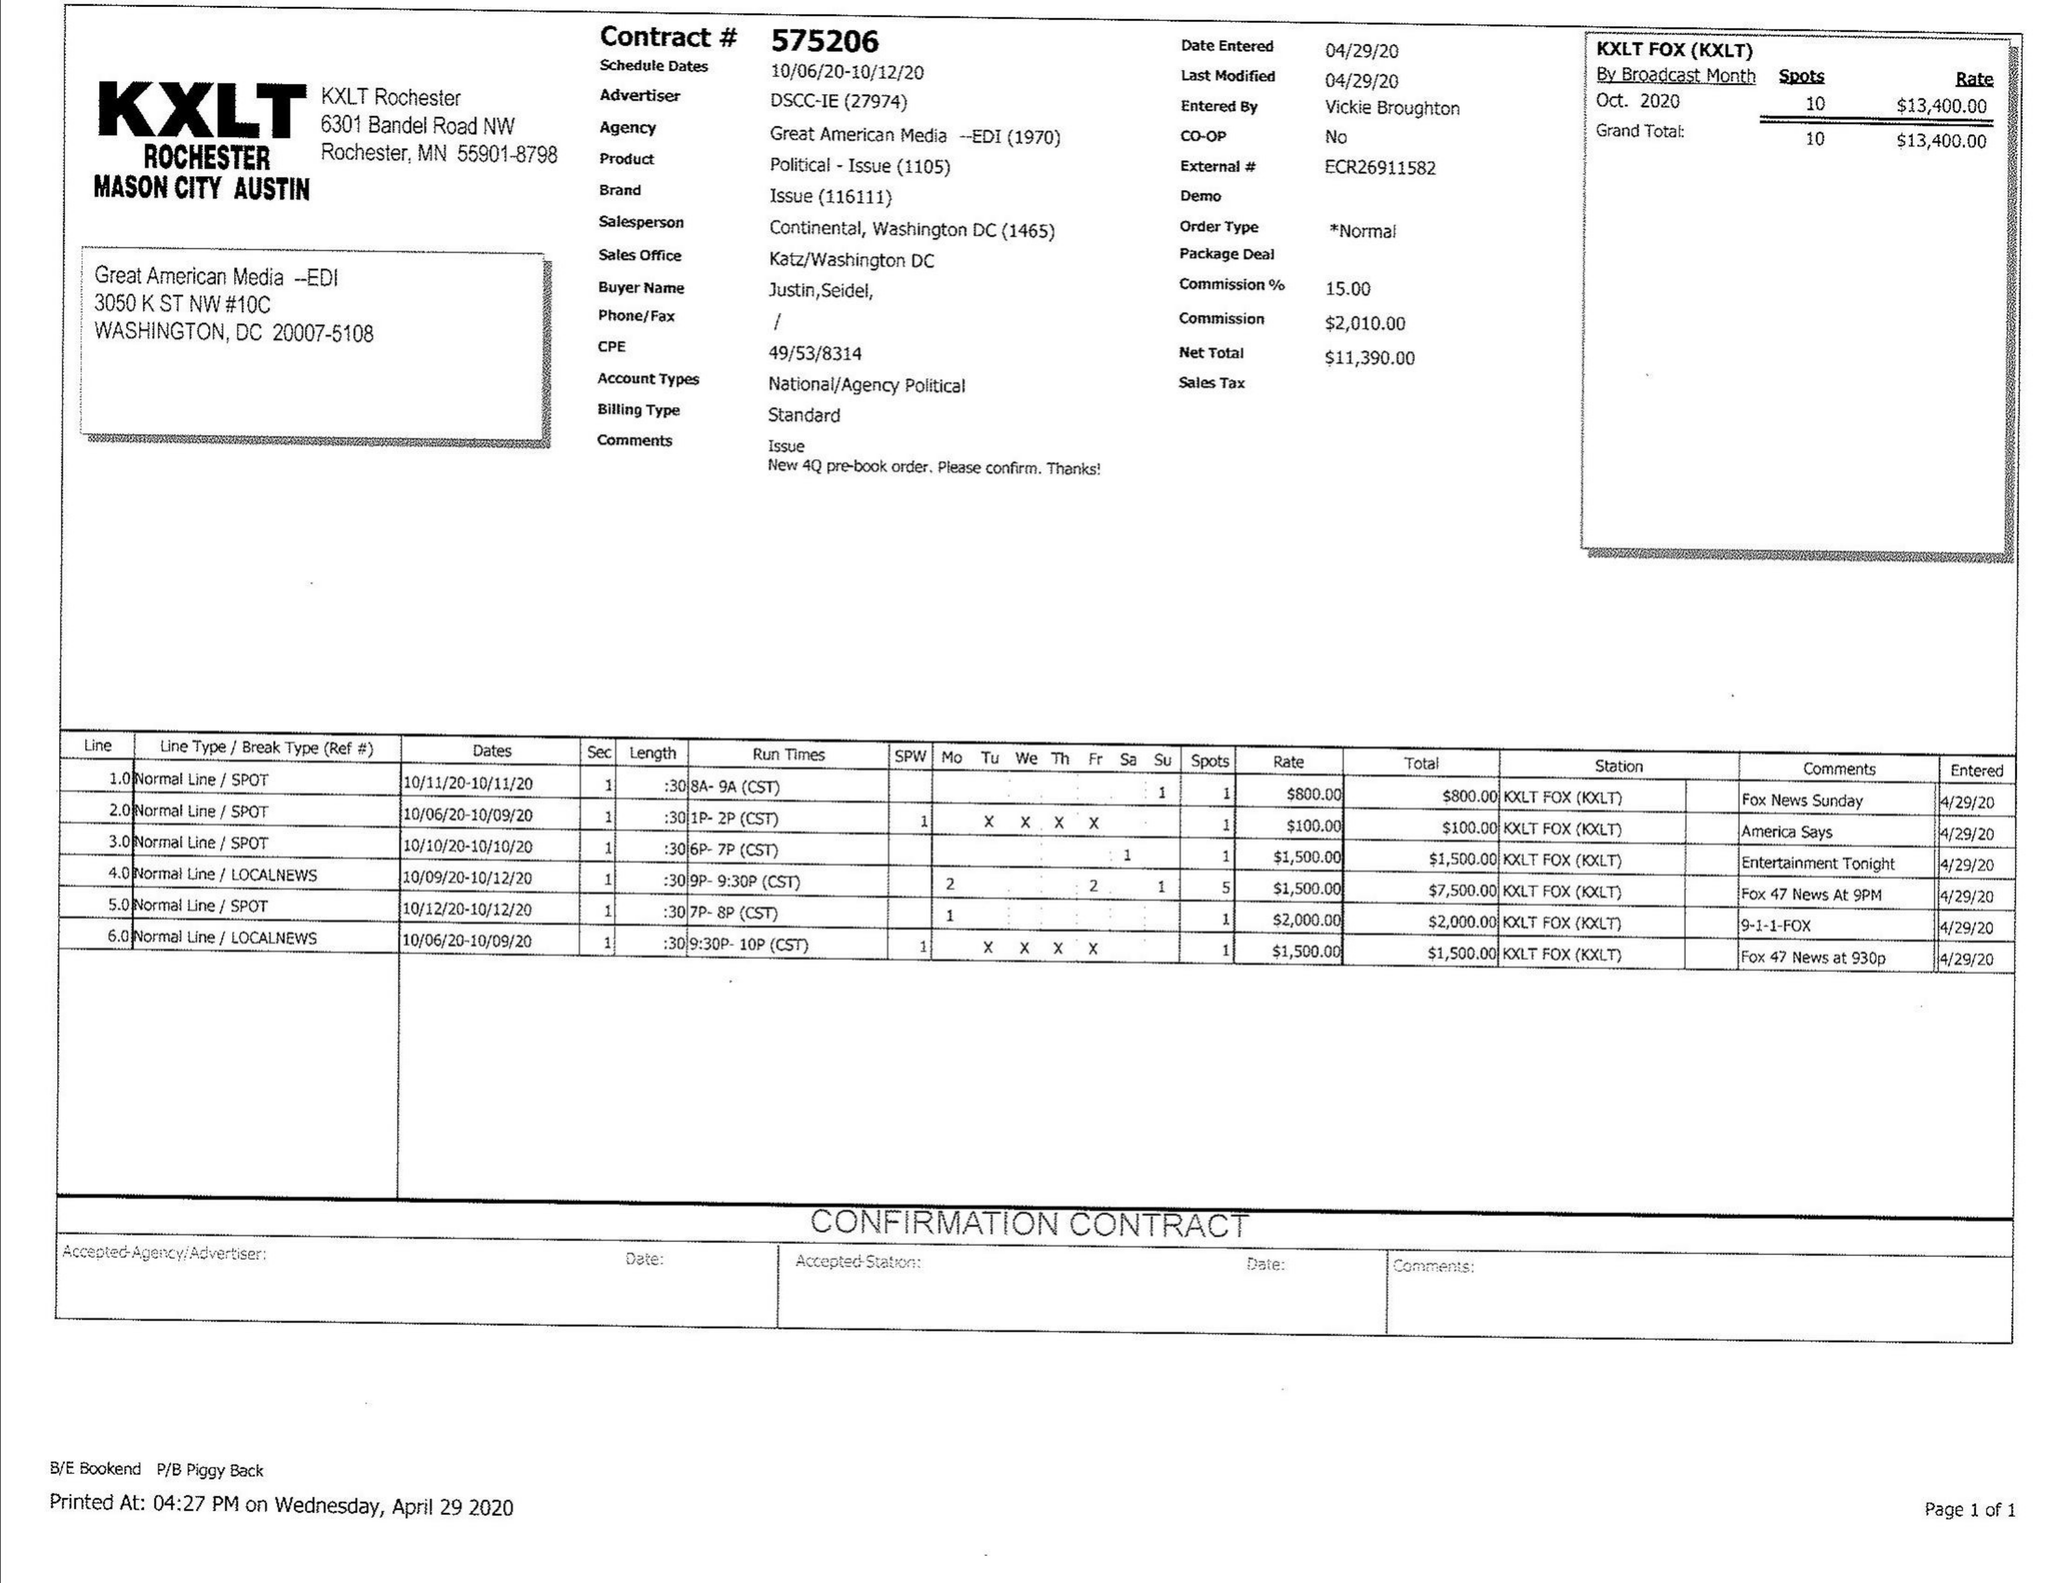What is the value for the flight_from?
Answer the question using a single word or phrase. 10/06/20 